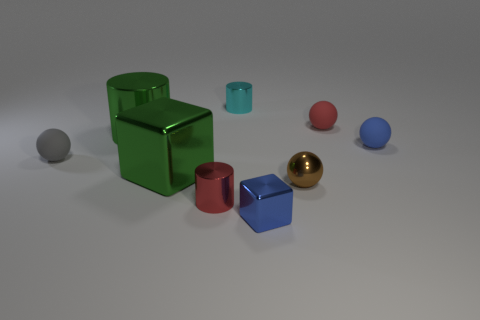Subtract all blue balls. How many balls are left? 3 Subtract 2 balls. How many balls are left? 2 Subtract all brown balls. How many balls are left? 3 Subtract all blocks. How many objects are left? 7 Add 1 big things. How many objects exist? 10 Add 1 things. How many things exist? 10 Subtract 0 brown cylinders. How many objects are left? 9 Subtract all purple cylinders. Subtract all blue blocks. How many cylinders are left? 3 Subtract all tiny shiny objects. Subtract all red spheres. How many objects are left? 4 Add 7 tiny red metallic cylinders. How many tiny red metallic cylinders are left? 8 